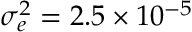<formula> <loc_0><loc_0><loc_500><loc_500>\sigma _ { e } ^ { 2 } = 2 . 5 \times 1 0 ^ { - 5 }</formula> 